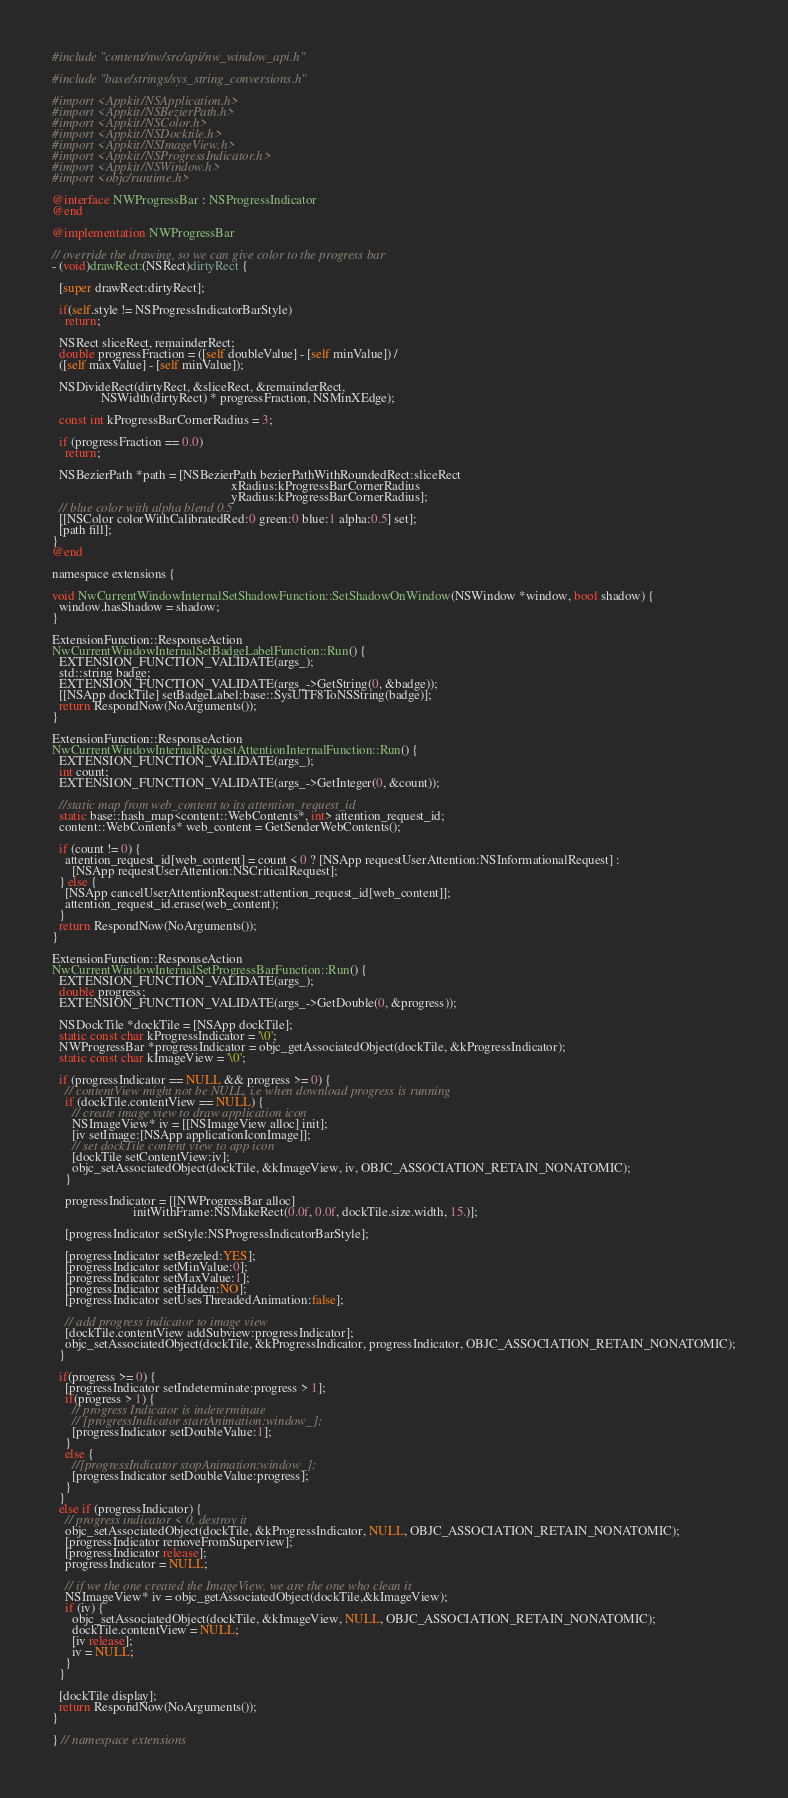Convert code to text. <code><loc_0><loc_0><loc_500><loc_500><_ObjectiveC_>#include "content/nw/src/api/nw_window_api.h"

#include "base/strings/sys_string_conversions.h"

#import <Appkit/NSApplication.h>
#import <Appkit/NSBezierPath.h>
#import <Appkit/NSColor.h>
#import <Appkit/NSDocktile.h>
#import <Appkit/NSImageView.h>
#import <Appkit/NSProgressIndicator.h>
#import <Appkit/NSWindow.h>
#import <objc/runtime.h>

@interface NWProgressBar : NSProgressIndicator
@end

@implementation NWProgressBar

// override the drawing, so we can give color to the progress bar
- (void)drawRect:(NSRect)dirtyRect {
  
  [super drawRect:dirtyRect];
  
  if(self.style != NSProgressIndicatorBarStyle)
    return;
  
  NSRect sliceRect, remainderRect;
  double progressFraction = ([self doubleValue] - [self minValue]) /
  ([self maxValue] - [self minValue]);
  
  NSDivideRect(dirtyRect, &sliceRect, &remainderRect,
               NSWidth(dirtyRect) * progressFraction, NSMinXEdge);
  
  const int kProgressBarCornerRadius = 3;
  
  if (progressFraction == 0.0)
    return;
  
  NSBezierPath *path = [NSBezierPath bezierPathWithRoundedRect:sliceRect
                                                       xRadius:kProgressBarCornerRadius
                                                       yRadius:kProgressBarCornerRadius];
  // blue color with alpha blend 0.5
  [[NSColor colorWithCalibratedRed:0 green:0 blue:1 alpha:0.5] set];
  [path fill];
}
@end

namespace extensions {

void NwCurrentWindowInternalSetShadowFunction::SetShadowOnWindow(NSWindow *window, bool shadow) {
  window.hasShadow = shadow;
}

ExtensionFunction::ResponseAction
NwCurrentWindowInternalSetBadgeLabelFunction::Run() {
  EXTENSION_FUNCTION_VALIDATE(args_);
  std::string badge;
  EXTENSION_FUNCTION_VALIDATE(args_->GetString(0, &badge));
  [[NSApp dockTile] setBadgeLabel:base::SysUTF8ToNSString(badge)];
  return RespondNow(NoArguments());
}

ExtensionFunction::ResponseAction
NwCurrentWindowInternalRequestAttentionInternalFunction::Run() {
  EXTENSION_FUNCTION_VALIDATE(args_);
  int count;
  EXTENSION_FUNCTION_VALIDATE(args_->GetInteger(0, &count));
  
  //static map from web_content to its attention_request_id
  static base::hash_map<content::WebContents*, int> attention_request_id;
  content::WebContents* web_content = GetSenderWebContents();
  
  if (count != 0) {
    attention_request_id[web_content] = count < 0 ? [NSApp requestUserAttention:NSInformationalRequest] :
      [NSApp requestUserAttention:NSCriticalRequest];
  } else {
    [NSApp cancelUserAttentionRequest:attention_request_id[web_content]];
    attention_request_id.erase(web_content);
  }
  return RespondNow(NoArguments());
}

ExtensionFunction::ResponseAction
NwCurrentWindowInternalSetProgressBarFunction::Run() {
  EXTENSION_FUNCTION_VALIDATE(args_);
  double progress;
  EXTENSION_FUNCTION_VALIDATE(args_->GetDouble(0, &progress));

  NSDockTile *dockTile = [NSApp dockTile];
  static const char kProgressIndicator = '\0';
  NWProgressBar *progressIndicator = objc_getAssociatedObject(dockTile, &kProgressIndicator);
  static const char kImageView = '\0';
  
  if (progressIndicator == NULL && progress >= 0) {
    // contentView might not be NULL, i.e when download progress is running
    if (dockTile.contentView == NULL) {
      // create image view to draw application icon
      NSImageView* iv = [[NSImageView alloc] init];
      [iv setImage:[NSApp applicationIconImage]];
      // set dockTile content view to app icon
      [dockTile setContentView:iv];
      objc_setAssociatedObject(dockTile, &kImageView, iv, OBJC_ASSOCIATION_RETAIN_NONATOMIC);
    }
    
    progressIndicator = [[NWProgressBar alloc]
                         initWithFrame:NSMakeRect(0.0f, 0.0f, dockTile.size.width, 15.)];
    
    [progressIndicator setStyle:NSProgressIndicatorBarStyle];
    
    [progressIndicator setBezeled:YES];
    [progressIndicator setMinValue:0];
    [progressIndicator setMaxValue:1];
    [progressIndicator setHidden:NO];
    [progressIndicator setUsesThreadedAnimation:false];
    
    // add progress indicator to image view
    [dockTile.contentView addSubview:progressIndicator];
    objc_setAssociatedObject(dockTile, &kProgressIndicator, progressIndicator, OBJC_ASSOCIATION_RETAIN_NONATOMIC);
  }

  if(progress >= 0) {
    [progressIndicator setIndeterminate:progress > 1];
    if(progress > 1) {
      // progress Indicator is indeterminate
      // [progressIndicator startAnimation:window_];
      [progressIndicator setDoubleValue:1];
    }
    else {
      //[progressIndicator stopAnimation:window_];
      [progressIndicator setDoubleValue:progress];
    }
  }
  else if (progressIndicator) {
    // progress indicator < 0, destroy it
    objc_setAssociatedObject(dockTile, &kProgressIndicator, NULL, OBJC_ASSOCIATION_RETAIN_NONATOMIC);
    [progressIndicator removeFromSuperview];
    [progressIndicator release];
    progressIndicator = NULL;

    // if we the one created the ImageView, we are the one who clean it
    NSImageView* iv = objc_getAssociatedObject(dockTile,&kImageView);
    if (iv) {
      objc_setAssociatedObject(dockTile, &kImageView, NULL, OBJC_ASSOCIATION_RETAIN_NONATOMIC);
      dockTile.contentView = NULL;
      [iv release];
      iv = NULL;
    }
  }
  
  [dockTile display];
  return RespondNow(NoArguments());
}

} // namespace extensions
</code> 